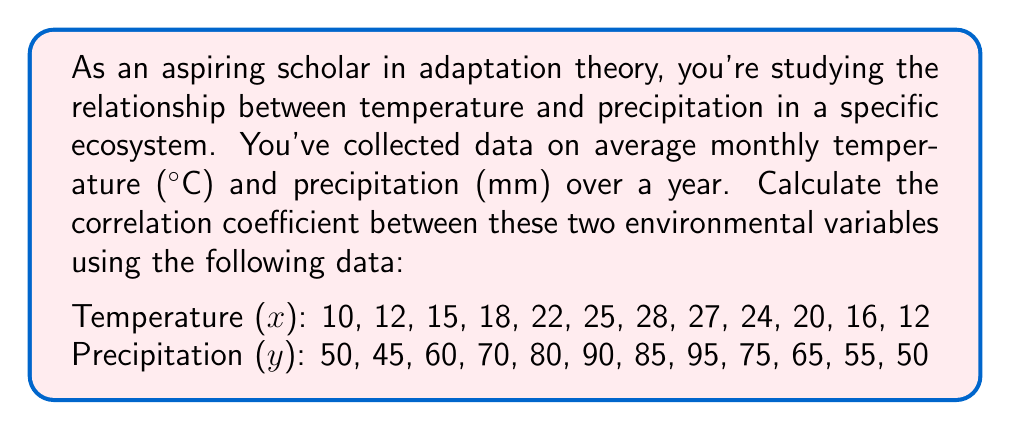Could you help me with this problem? To calculate the correlation coefficient (r), we'll use the formula:

$$ r = \frac{n\sum xy - \sum x \sum y}{\sqrt{[n\sum x^2 - (\sum x)^2][n\sum y^2 - (\sum y)^2]}} $$

Step 1: Calculate the necessary sums:
$n = 12$ (number of data points)
$\sum x = 229$
$\sum y = 820$
$\sum xy = 16,025$
$\sum x^2 = 4,641$
$\sum y^2 = 58,750$

Step 2: Calculate $(\sum x)^2$ and $(\sum y)^2$:
$(\sum x)^2 = 229^2 = 52,441$
$(\sum y)^2 = 820^2 = 672,400$

Step 3: Substitute values into the correlation coefficient formula:

$$ r = \frac{12(16,025) - (229)(820)}{\sqrt{[12(4,641) - 52,441][12(58,750) - 672,400]}} $$

Step 4: Simplify:

$$ r = \frac{192,300 - 187,780}{\sqrt{(55,692 - 52,441)(705,000 - 672,400)}} $$

$$ r = \frac{4,520}{\sqrt{(3,251)(32,600)}} $$

$$ r = \frac{4,520}{\sqrt{105,982,600}} $$

$$ r = \frac{4,520}{10,295.09} $$

$$ r \approx 0.4390 $$
Answer: $r \approx 0.4390$ 